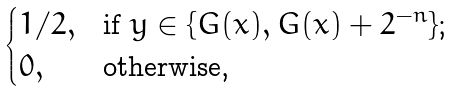Convert formula to latex. <formula><loc_0><loc_0><loc_500><loc_500>\begin{cases} 1 / 2 , & \text {if $y\in\{G(x),G(x)+2^{-n}\}$;} \\ 0 , & \text {otherwise,} \end{cases}</formula> 